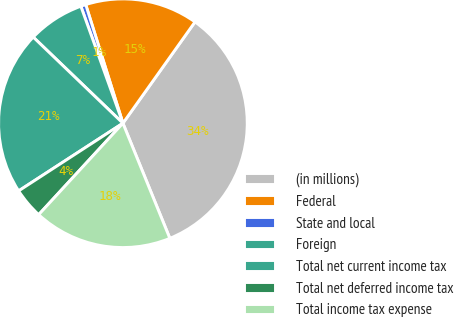Convert chart to OTSL. <chart><loc_0><loc_0><loc_500><loc_500><pie_chart><fcel>(in millions)<fcel>Federal<fcel>State and local<fcel>Foreign<fcel>Total net current income tax<fcel>Total net deferred income tax<fcel>Total income tax expense<nl><fcel>34.0%<fcel>14.68%<fcel>0.66%<fcel>7.33%<fcel>21.34%<fcel>3.99%<fcel>18.01%<nl></chart> 